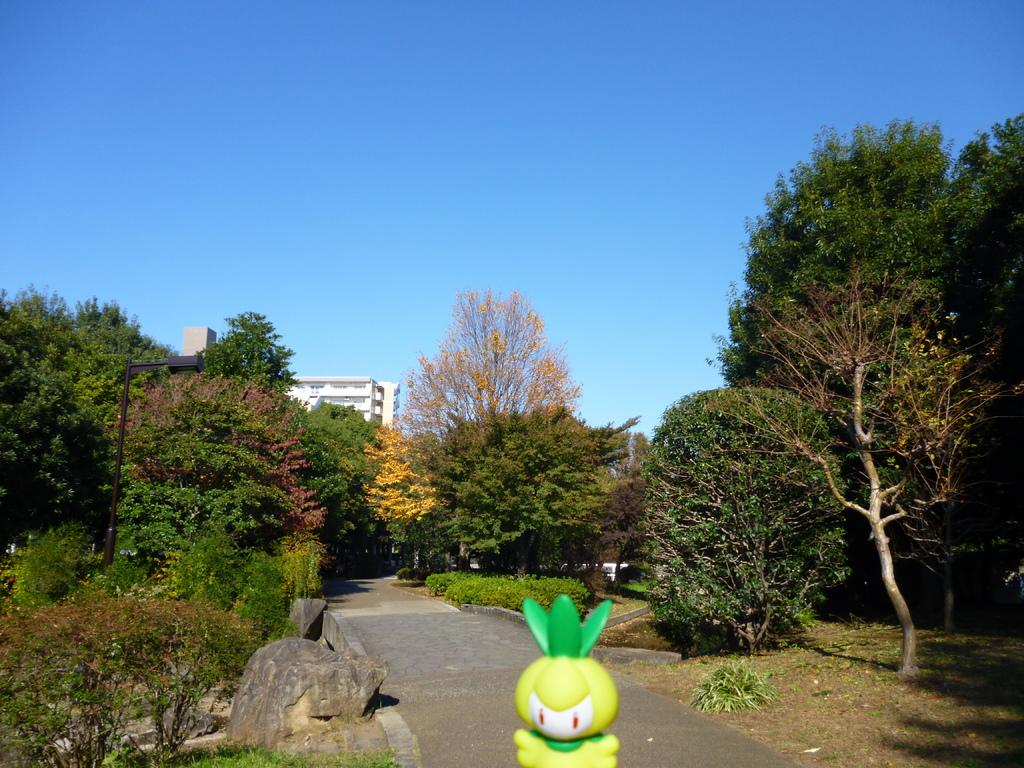What is located in the foreground of the image? There is a toy, a rock, and plants in the foreground of the image. What can be seen in the background of the image? There are trees and buildings in the background of the image. What is the color of the sky in the image? The sky is blue in the image. When was the image taken? The image was taken during the day. What type of sign can be seen on the toy in the image? There is no sign present on the toy in the image. What color is the paint on the rock in the image? There is no paint on the rock in the image; it is a natural rock. 